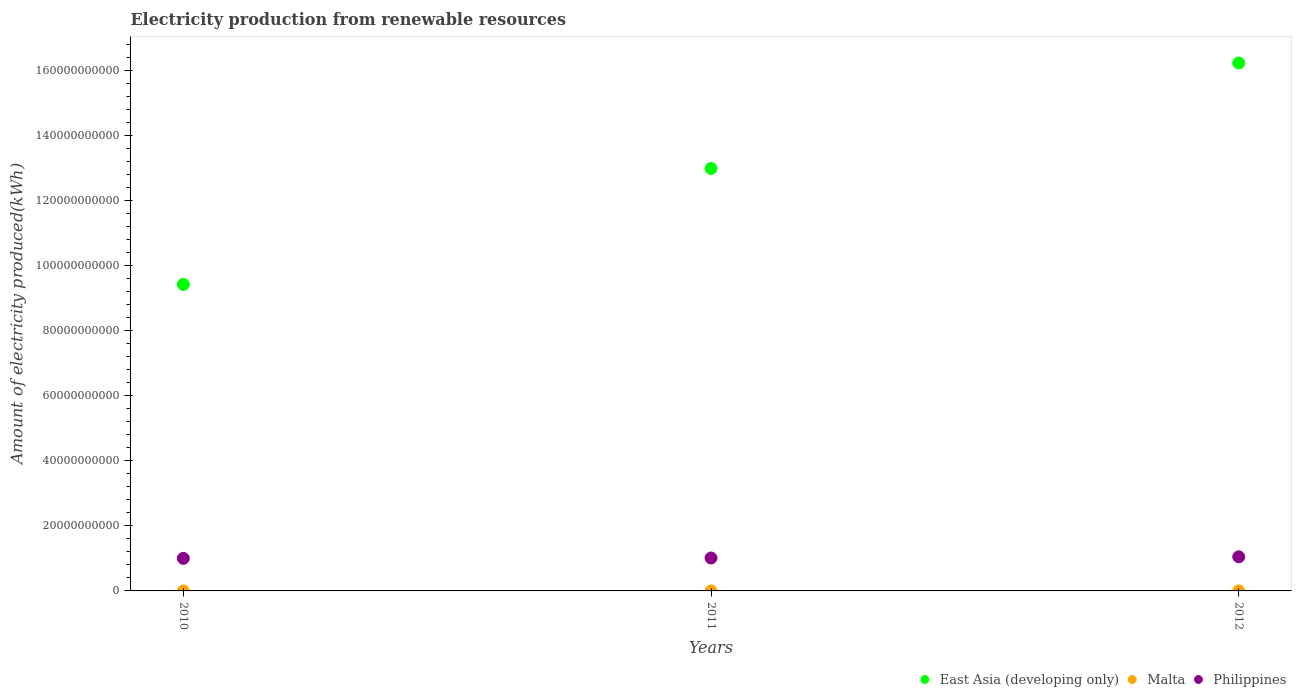Is the number of dotlines equal to the number of legend labels?
Keep it short and to the point. Yes. What is the amount of electricity produced in East Asia (developing only) in 2010?
Your answer should be compact. 9.42e+1. Across all years, what is the maximum amount of electricity produced in Philippines?
Provide a short and direct response. 1.05e+1. Across all years, what is the minimum amount of electricity produced in East Asia (developing only)?
Offer a very short reply. 9.42e+1. What is the total amount of electricity produced in East Asia (developing only) in the graph?
Give a very brief answer. 3.86e+11. What is the difference between the amount of electricity produced in Malta in 2010 and that in 2011?
Your answer should be compact. -1.10e+07. What is the difference between the amount of electricity produced in Philippines in 2011 and the amount of electricity produced in East Asia (developing only) in 2012?
Make the answer very short. -1.52e+11. What is the average amount of electricity produced in East Asia (developing only) per year?
Keep it short and to the point. 1.29e+11. In the year 2012, what is the difference between the amount of electricity produced in Philippines and amount of electricity produced in Malta?
Your answer should be compact. 1.05e+1. In how many years, is the amount of electricity produced in East Asia (developing only) greater than 84000000000 kWh?
Provide a short and direct response. 3. What is the ratio of the amount of electricity produced in Malta in 2011 to that in 2012?
Ensure brevity in your answer.  0.52. What is the difference between the highest and the lowest amount of electricity produced in East Asia (developing only)?
Make the answer very short. 6.81e+1. Is the sum of the amount of electricity produced in Philippines in 2010 and 2011 greater than the maximum amount of electricity produced in Malta across all years?
Your answer should be very brief. Yes. Is it the case that in every year, the sum of the amount of electricity produced in Malta and amount of electricity produced in Philippines  is greater than the amount of electricity produced in East Asia (developing only)?
Your answer should be very brief. No. How many dotlines are there?
Ensure brevity in your answer.  3. Does the graph contain grids?
Provide a short and direct response. No. How many legend labels are there?
Offer a terse response. 3. What is the title of the graph?
Make the answer very short. Electricity production from renewable resources. Does "Mozambique" appear as one of the legend labels in the graph?
Your answer should be very brief. No. What is the label or title of the Y-axis?
Offer a very short reply. Amount of electricity produced(kWh). What is the Amount of electricity produced(kWh) in East Asia (developing only) in 2010?
Your answer should be compact. 9.42e+1. What is the Amount of electricity produced(kWh) in Philippines in 2010?
Your answer should be compact. 1.00e+1. What is the Amount of electricity produced(kWh) in East Asia (developing only) in 2011?
Your answer should be very brief. 1.30e+11. What is the Amount of electricity produced(kWh) in Malta in 2011?
Offer a very short reply. 1.30e+07. What is the Amount of electricity produced(kWh) in Philippines in 2011?
Provide a succinct answer. 1.01e+1. What is the Amount of electricity produced(kWh) in East Asia (developing only) in 2012?
Make the answer very short. 1.62e+11. What is the Amount of electricity produced(kWh) in Malta in 2012?
Ensure brevity in your answer.  2.50e+07. What is the Amount of electricity produced(kWh) in Philippines in 2012?
Offer a very short reply. 1.05e+1. Across all years, what is the maximum Amount of electricity produced(kWh) in East Asia (developing only)?
Your response must be concise. 1.62e+11. Across all years, what is the maximum Amount of electricity produced(kWh) in Malta?
Provide a short and direct response. 2.50e+07. Across all years, what is the maximum Amount of electricity produced(kWh) in Philippines?
Give a very brief answer. 1.05e+1. Across all years, what is the minimum Amount of electricity produced(kWh) of East Asia (developing only)?
Provide a succinct answer. 9.42e+1. Across all years, what is the minimum Amount of electricity produced(kWh) of Malta?
Provide a short and direct response. 2.00e+06. Across all years, what is the minimum Amount of electricity produced(kWh) of Philippines?
Ensure brevity in your answer.  1.00e+1. What is the total Amount of electricity produced(kWh) in East Asia (developing only) in the graph?
Make the answer very short. 3.86e+11. What is the total Amount of electricity produced(kWh) in Malta in the graph?
Provide a short and direct response. 4.00e+07. What is the total Amount of electricity produced(kWh) of Philippines in the graph?
Provide a succinct answer. 3.06e+1. What is the difference between the Amount of electricity produced(kWh) of East Asia (developing only) in 2010 and that in 2011?
Your answer should be compact. -3.56e+1. What is the difference between the Amount of electricity produced(kWh) of Malta in 2010 and that in 2011?
Give a very brief answer. -1.10e+07. What is the difference between the Amount of electricity produced(kWh) in Philippines in 2010 and that in 2011?
Provide a succinct answer. -1.13e+08. What is the difference between the Amount of electricity produced(kWh) in East Asia (developing only) in 2010 and that in 2012?
Ensure brevity in your answer.  -6.81e+1. What is the difference between the Amount of electricity produced(kWh) of Malta in 2010 and that in 2012?
Provide a short and direct response. -2.30e+07. What is the difference between the Amount of electricity produced(kWh) in Philippines in 2010 and that in 2012?
Ensure brevity in your answer.  -4.78e+08. What is the difference between the Amount of electricity produced(kWh) in East Asia (developing only) in 2011 and that in 2012?
Your answer should be compact. -3.24e+1. What is the difference between the Amount of electricity produced(kWh) in Malta in 2011 and that in 2012?
Ensure brevity in your answer.  -1.20e+07. What is the difference between the Amount of electricity produced(kWh) in Philippines in 2011 and that in 2012?
Offer a very short reply. -3.65e+08. What is the difference between the Amount of electricity produced(kWh) of East Asia (developing only) in 2010 and the Amount of electricity produced(kWh) of Malta in 2011?
Ensure brevity in your answer.  9.42e+1. What is the difference between the Amount of electricity produced(kWh) in East Asia (developing only) in 2010 and the Amount of electricity produced(kWh) in Philippines in 2011?
Provide a short and direct response. 8.41e+1. What is the difference between the Amount of electricity produced(kWh) in Malta in 2010 and the Amount of electricity produced(kWh) in Philippines in 2011?
Your answer should be very brief. -1.01e+1. What is the difference between the Amount of electricity produced(kWh) in East Asia (developing only) in 2010 and the Amount of electricity produced(kWh) in Malta in 2012?
Provide a short and direct response. 9.42e+1. What is the difference between the Amount of electricity produced(kWh) in East Asia (developing only) in 2010 and the Amount of electricity produced(kWh) in Philippines in 2012?
Your answer should be compact. 8.38e+1. What is the difference between the Amount of electricity produced(kWh) in Malta in 2010 and the Amount of electricity produced(kWh) in Philippines in 2012?
Provide a short and direct response. -1.05e+1. What is the difference between the Amount of electricity produced(kWh) in East Asia (developing only) in 2011 and the Amount of electricity produced(kWh) in Malta in 2012?
Ensure brevity in your answer.  1.30e+11. What is the difference between the Amount of electricity produced(kWh) in East Asia (developing only) in 2011 and the Amount of electricity produced(kWh) in Philippines in 2012?
Ensure brevity in your answer.  1.19e+11. What is the difference between the Amount of electricity produced(kWh) in Malta in 2011 and the Amount of electricity produced(kWh) in Philippines in 2012?
Your answer should be very brief. -1.05e+1. What is the average Amount of electricity produced(kWh) in East Asia (developing only) per year?
Keep it short and to the point. 1.29e+11. What is the average Amount of electricity produced(kWh) in Malta per year?
Your response must be concise. 1.33e+07. What is the average Amount of electricity produced(kWh) in Philippines per year?
Provide a succinct answer. 1.02e+1. In the year 2010, what is the difference between the Amount of electricity produced(kWh) in East Asia (developing only) and Amount of electricity produced(kWh) in Malta?
Your response must be concise. 9.42e+1. In the year 2010, what is the difference between the Amount of electricity produced(kWh) of East Asia (developing only) and Amount of electricity produced(kWh) of Philippines?
Give a very brief answer. 8.42e+1. In the year 2010, what is the difference between the Amount of electricity produced(kWh) in Malta and Amount of electricity produced(kWh) in Philippines?
Your answer should be compact. -1.00e+1. In the year 2011, what is the difference between the Amount of electricity produced(kWh) in East Asia (developing only) and Amount of electricity produced(kWh) in Malta?
Provide a succinct answer. 1.30e+11. In the year 2011, what is the difference between the Amount of electricity produced(kWh) of East Asia (developing only) and Amount of electricity produced(kWh) of Philippines?
Your answer should be compact. 1.20e+11. In the year 2011, what is the difference between the Amount of electricity produced(kWh) in Malta and Amount of electricity produced(kWh) in Philippines?
Offer a terse response. -1.01e+1. In the year 2012, what is the difference between the Amount of electricity produced(kWh) in East Asia (developing only) and Amount of electricity produced(kWh) in Malta?
Offer a terse response. 1.62e+11. In the year 2012, what is the difference between the Amount of electricity produced(kWh) of East Asia (developing only) and Amount of electricity produced(kWh) of Philippines?
Your response must be concise. 1.52e+11. In the year 2012, what is the difference between the Amount of electricity produced(kWh) in Malta and Amount of electricity produced(kWh) in Philippines?
Provide a succinct answer. -1.05e+1. What is the ratio of the Amount of electricity produced(kWh) of East Asia (developing only) in 2010 to that in 2011?
Your answer should be very brief. 0.73. What is the ratio of the Amount of electricity produced(kWh) in Malta in 2010 to that in 2011?
Your answer should be compact. 0.15. What is the ratio of the Amount of electricity produced(kWh) of East Asia (developing only) in 2010 to that in 2012?
Keep it short and to the point. 0.58. What is the ratio of the Amount of electricity produced(kWh) in Malta in 2010 to that in 2012?
Provide a succinct answer. 0.08. What is the ratio of the Amount of electricity produced(kWh) of Philippines in 2010 to that in 2012?
Ensure brevity in your answer.  0.95. What is the ratio of the Amount of electricity produced(kWh) in East Asia (developing only) in 2011 to that in 2012?
Your answer should be compact. 0.8. What is the ratio of the Amount of electricity produced(kWh) of Malta in 2011 to that in 2012?
Offer a terse response. 0.52. What is the ratio of the Amount of electricity produced(kWh) in Philippines in 2011 to that in 2012?
Offer a terse response. 0.97. What is the difference between the highest and the second highest Amount of electricity produced(kWh) of East Asia (developing only)?
Make the answer very short. 3.24e+1. What is the difference between the highest and the second highest Amount of electricity produced(kWh) in Malta?
Offer a terse response. 1.20e+07. What is the difference between the highest and the second highest Amount of electricity produced(kWh) in Philippines?
Your answer should be compact. 3.65e+08. What is the difference between the highest and the lowest Amount of electricity produced(kWh) of East Asia (developing only)?
Provide a succinct answer. 6.81e+1. What is the difference between the highest and the lowest Amount of electricity produced(kWh) of Malta?
Offer a terse response. 2.30e+07. What is the difference between the highest and the lowest Amount of electricity produced(kWh) in Philippines?
Your answer should be compact. 4.78e+08. 